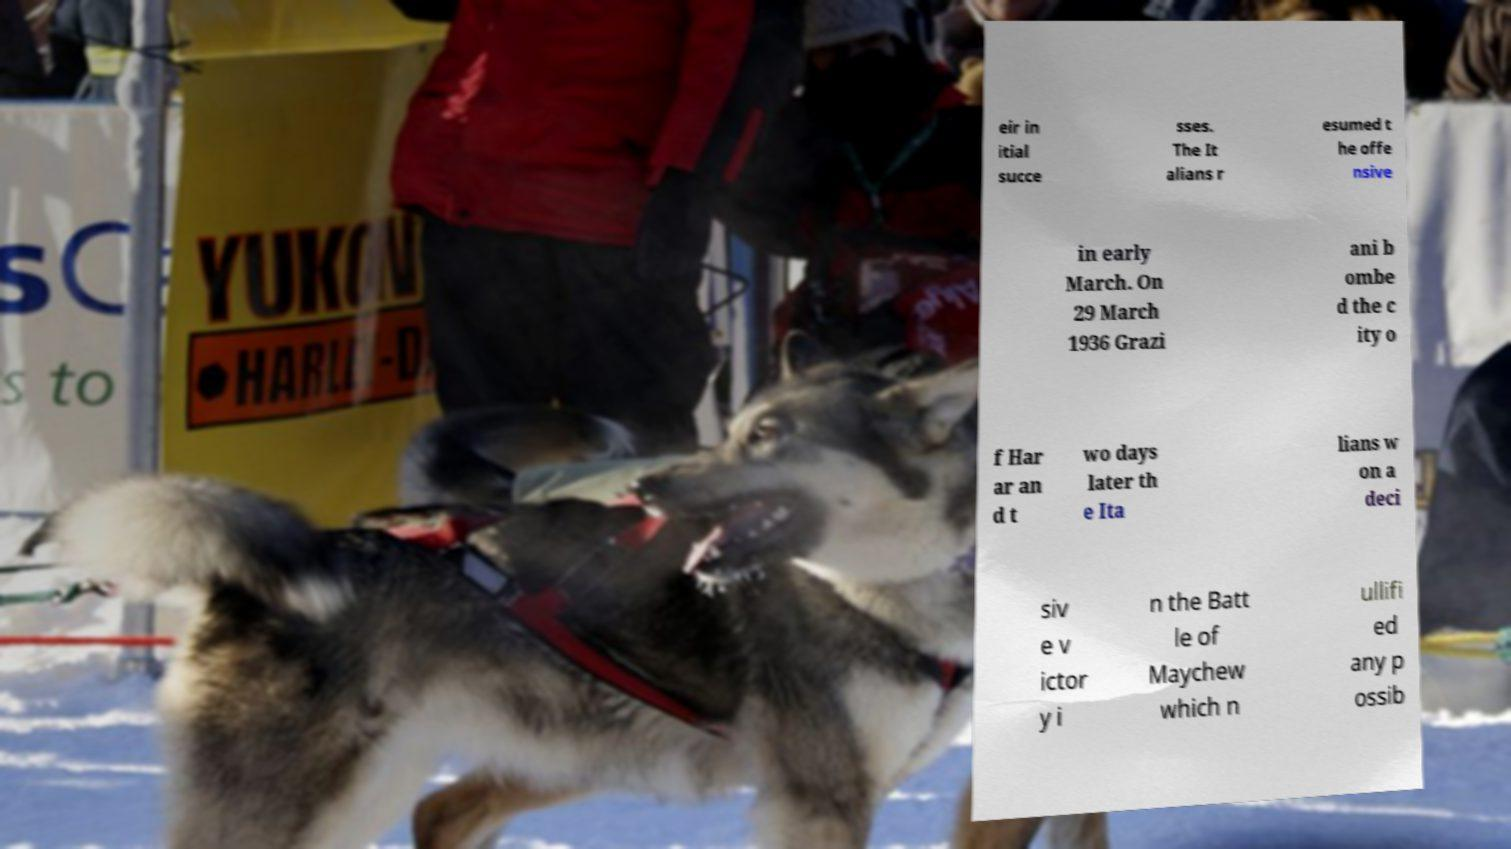Could you extract and type out the text from this image? eir in itial succe sses. The It alians r esumed t he offe nsive in early March. On 29 March 1936 Grazi ani b ombe d the c ity o f Har ar an d t wo days later th e Ita lians w on a deci siv e v ictor y i n the Batt le of Maychew which n ullifi ed any p ossib 